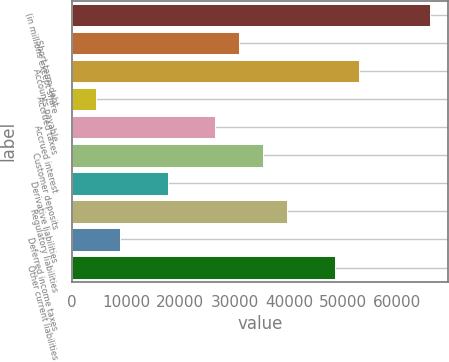Convert chart to OTSL. <chart><loc_0><loc_0><loc_500><loc_500><bar_chart><fcel>(in millions except share<fcel>Short-term debt<fcel>Accounts payable<fcel>Accrued taxes<fcel>Accrued interest<fcel>Customer deposits<fcel>Derivative liabilities<fcel>Regulatory liabilities<fcel>Deferred income taxes<fcel>Other current liabilities<nl><fcel>66036.5<fcel>30832.5<fcel>52835<fcel>4429.5<fcel>26432<fcel>35233<fcel>17631<fcel>39633.5<fcel>8830<fcel>48434.5<nl></chart> 